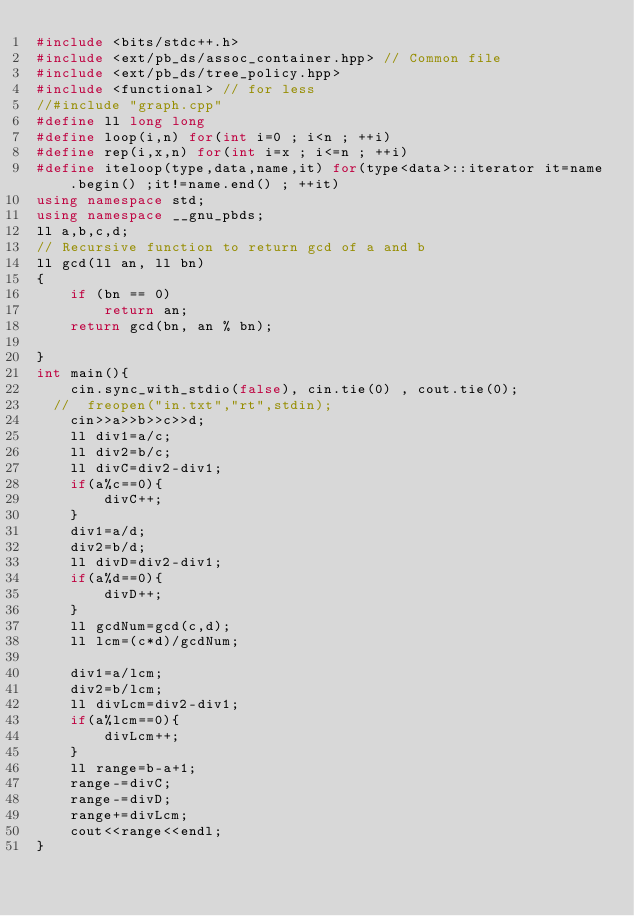Convert code to text. <code><loc_0><loc_0><loc_500><loc_500><_C++_>#include <bits/stdc++.h>
#include <ext/pb_ds/assoc_container.hpp> // Common file
#include <ext/pb_ds/tree_policy.hpp>
#include <functional> // for less
//#include "graph.cpp"
#define ll long long
#define loop(i,n) for(int i=0 ; i<n ; ++i)
#define rep(i,x,n) for(int i=x ; i<=n ; ++i)
#define iteloop(type,data,name,it) for(type<data>::iterator it=name.begin() ;it!=name.end() ; ++it)
using namespace std;
using namespace __gnu_pbds;
ll a,b,c,d;
// Recursive function to return gcd of a and b
ll gcd(ll an, ll bn)
{
    if (bn == 0)
        return an;
    return gcd(bn, an % bn);
 
}
int main(){
    cin.sync_with_stdio(false), cin.tie(0) , cout.tie(0);
  //  freopen("in.txt","rt",stdin);
    cin>>a>>b>>c>>d;
    ll div1=a/c;
    ll div2=b/c;
    ll divC=div2-div1;
    if(a%c==0){
        divC++;
    }
    div1=a/d;
    div2=b/d;
    ll divD=div2-div1;
    if(a%d==0){
        divD++;
    }
    ll gcdNum=gcd(c,d);
    ll lcm=(c*d)/gcdNum;
 
    div1=a/lcm;
    div2=b/lcm;
    ll divLcm=div2-div1;
    if(a%lcm==0){
        divLcm++;
    }
    ll range=b-a+1;
    range-=divC;
    range-=divD;
    range+=divLcm;
    cout<<range<<endl;
}</code> 